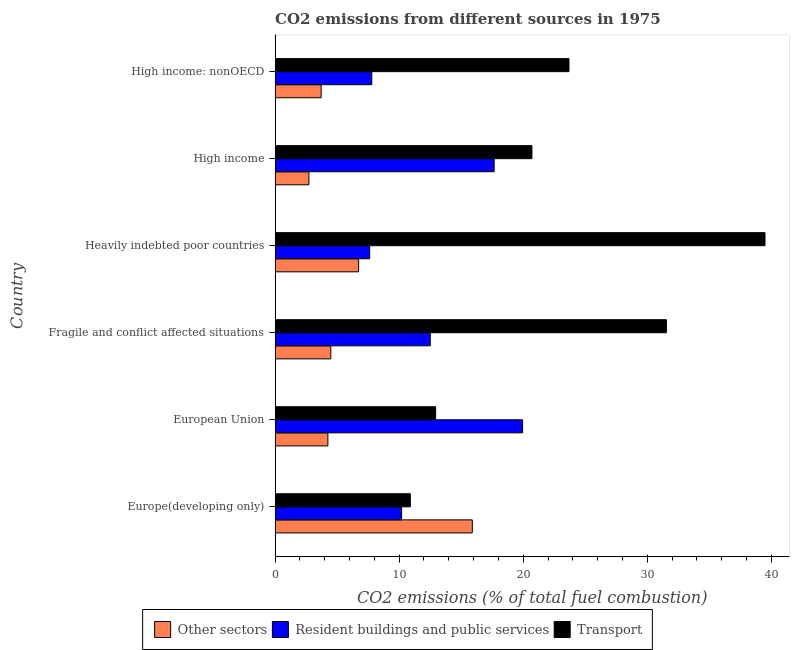How many groups of bars are there?
Offer a very short reply. 6. Are the number of bars on each tick of the Y-axis equal?
Your response must be concise. Yes. How many bars are there on the 3rd tick from the top?
Ensure brevity in your answer.  3. What is the label of the 6th group of bars from the top?
Offer a terse response. Europe(developing only). What is the percentage of co2 emissions from other sectors in High income?
Provide a succinct answer. 2.73. Across all countries, what is the maximum percentage of co2 emissions from transport?
Provide a short and direct response. 39.49. Across all countries, what is the minimum percentage of co2 emissions from other sectors?
Offer a very short reply. 2.73. In which country was the percentage of co2 emissions from resident buildings and public services minimum?
Offer a very short reply. Heavily indebted poor countries. What is the total percentage of co2 emissions from resident buildings and public services in the graph?
Your answer should be very brief. 75.72. What is the difference between the percentage of co2 emissions from other sectors in Europe(developing only) and that in High income?
Offer a very short reply. 13.17. What is the difference between the percentage of co2 emissions from transport in Fragile and conflict affected situations and the percentage of co2 emissions from resident buildings and public services in European Union?
Offer a terse response. 11.59. What is the average percentage of co2 emissions from other sectors per country?
Your response must be concise. 6.3. What is the difference between the percentage of co2 emissions from other sectors and percentage of co2 emissions from resident buildings and public services in High income: nonOECD?
Provide a short and direct response. -4.08. What is the ratio of the percentage of co2 emissions from transport in Europe(developing only) to that in High income?
Provide a succinct answer. 0.53. Is the percentage of co2 emissions from resident buildings and public services in Fragile and conflict affected situations less than that in High income: nonOECD?
Your answer should be very brief. No. Is the difference between the percentage of co2 emissions from transport in Heavily indebted poor countries and High income: nonOECD greater than the difference between the percentage of co2 emissions from resident buildings and public services in Heavily indebted poor countries and High income: nonOECD?
Provide a short and direct response. Yes. What is the difference between the highest and the second highest percentage of co2 emissions from resident buildings and public services?
Give a very brief answer. 2.3. What is the difference between the highest and the lowest percentage of co2 emissions from transport?
Your response must be concise. 28.58. In how many countries, is the percentage of co2 emissions from transport greater than the average percentage of co2 emissions from transport taken over all countries?
Provide a short and direct response. 3. What does the 2nd bar from the top in European Union represents?
Make the answer very short. Resident buildings and public services. What does the 1st bar from the bottom in Fragile and conflict affected situations represents?
Ensure brevity in your answer.  Other sectors. Is it the case that in every country, the sum of the percentage of co2 emissions from other sectors and percentage of co2 emissions from resident buildings and public services is greater than the percentage of co2 emissions from transport?
Offer a terse response. No. How many bars are there?
Keep it short and to the point. 18. What is the difference between two consecutive major ticks on the X-axis?
Ensure brevity in your answer.  10. Are the values on the major ticks of X-axis written in scientific E-notation?
Offer a very short reply. No. Does the graph contain grids?
Give a very brief answer. No. Where does the legend appear in the graph?
Provide a short and direct response. Bottom center. How are the legend labels stacked?
Your answer should be very brief. Horizontal. What is the title of the graph?
Offer a very short reply. CO2 emissions from different sources in 1975. Does "Self-employed" appear as one of the legend labels in the graph?
Provide a short and direct response. No. What is the label or title of the X-axis?
Provide a short and direct response. CO2 emissions (% of total fuel combustion). What is the CO2 emissions (% of total fuel combustion) in Other sectors in Europe(developing only)?
Make the answer very short. 15.89. What is the CO2 emissions (% of total fuel combustion) of Resident buildings and public services in Europe(developing only)?
Keep it short and to the point. 10.2. What is the CO2 emissions (% of total fuel combustion) in Transport in Europe(developing only)?
Give a very brief answer. 10.9. What is the CO2 emissions (% of total fuel combustion) of Other sectors in European Union?
Ensure brevity in your answer.  4.26. What is the CO2 emissions (% of total fuel combustion) of Resident buildings and public services in European Union?
Your answer should be very brief. 19.95. What is the CO2 emissions (% of total fuel combustion) in Transport in European Union?
Provide a short and direct response. 12.94. What is the CO2 emissions (% of total fuel combustion) of Other sectors in Fragile and conflict affected situations?
Provide a succinct answer. 4.49. What is the CO2 emissions (% of total fuel combustion) in Resident buildings and public services in Fragile and conflict affected situations?
Offer a very short reply. 12.51. What is the CO2 emissions (% of total fuel combustion) of Transport in Fragile and conflict affected situations?
Your response must be concise. 31.54. What is the CO2 emissions (% of total fuel combustion) of Other sectors in Heavily indebted poor countries?
Offer a very short reply. 6.73. What is the CO2 emissions (% of total fuel combustion) in Resident buildings and public services in Heavily indebted poor countries?
Provide a succinct answer. 7.62. What is the CO2 emissions (% of total fuel combustion) in Transport in Heavily indebted poor countries?
Offer a terse response. 39.49. What is the CO2 emissions (% of total fuel combustion) in Other sectors in High income?
Provide a short and direct response. 2.73. What is the CO2 emissions (% of total fuel combustion) of Resident buildings and public services in High income?
Offer a very short reply. 17.65. What is the CO2 emissions (% of total fuel combustion) of Transport in High income?
Keep it short and to the point. 20.7. What is the CO2 emissions (% of total fuel combustion) of Other sectors in High income: nonOECD?
Keep it short and to the point. 3.71. What is the CO2 emissions (% of total fuel combustion) of Resident buildings and public services in High income: nonOECD?
Your answer should be very brief. 7.79. What is the CO2 emissions (% of total fuel combustion) in Transport in High income: nonOECD?
Ensure brevity in your answer.  23.69. Across all countries, what is the maximum CO2 emissions (% of total fuel combustion) in Other sectors?
Make the answer very short. 15.89. Across all countries, what is the maximum CO2 emissions (% of total fuel combustion) of Resident buildings and public services?
Provide a short and direct response. 19.95. Across all countries, what is the maximum CO2 emissions (% of total fuel combustion) of Transport?
Provide a short and direct response. 39.49. Across all countries, what is the minimum CO2 emissions (% of total fuel combustion) of Other sectors?
Give a very brief answer. 2.73. Across all countries, what is the minimum CO2 emissions (% of total fuel combustion) of Resident buildings and public services?
Provide a succinct answer. 7.62. Across all countries, what is the minimum CO2 emissions (% of total fuel combustion) in Transport?
Offer a terse response. 10.9. What is the total CO2 emissions (% of total fuel combustion) of Other sectors in the graph?
Your answer should be compact. 37.82. What is the total CO2 emissions (% of total fuel combustion) of Resident buildings and public services in the graph?
Provide a succinct answer. 75.72. What is the total CO2 emissions (% of total fuel combustion) of Transport in the graph?
Provide a short and direct response. 139.26. What is the difference between the CO2 emissions (% of total fuel combustion) of Other sectors in Europe(developing only) and that in European Union?
Your response must be concise. 11.64. What is the difference between the CO2 emissions (% of total fuel combustion) of Resident buildings and public services in Europe(developing only) and that in European Union?
Provide a short and direct response. -9.75. What is the difference between the CO2 emissions (% of total fuel combustion) of Transport in Europe(developing only) and that in European Union?
Offer a terse response. -2.04. What is the difference between the CO2 emissions (% of total fuel combustion) of Other sectors in Europe(developing only) and that in Fragile and conflict affected situations?
Your response must be concise. 11.4. What is the difference between the CO2 emissions (% of total fuel combustion) in Resident buildings and public services in Europe(developing only) and that in Fragile and conflict affected situations?
Provide a short and direct response. -2.31. What is the difference between the CO2 emissions (% of total fuel combustion) of Transport in Europe(developing only) and that in Fragile and conflict affected situations?
Your response must be concise. -20.64. What is the difference between the CO2 emissions (% of total fuel combustion) in Other sectors in Europe(developing only) and that in Heavily indebted poor countries?
Give a very brief answer. 9.16. What is the difference between the CO2 emissions (% of total fuel combustion) in Resident buildings and public services in Europe(developing only) and that in Heavily indebted poor countries?
Keep it short and to the point. 2.57. What is the difference between the CO2 emissions (% of total fuel combustion) of Transport in Europe(developing only) and that in Heavily indebted poor countries?
Your answer should be very brief. -28.58. What is the difference between the CO2 emissions (% of total fuel combustion) in Other sectors in Europe(developing only) and that in High income?
Ensure brevity in your answer.  13.17. What is the difference between the CO2 emissions (% of total fuel combustion) in Resident buildings and public services in Europe(developing only) and that in High income?
Provide a short and direct response. -7.46. What is the difference between the CO2 emissions (% of total fuel combustion) of Transport in Europe(developing only) and that in High income?
Your answer should be compact. -9.8. What is the difference between the CO2 emissions (% of total fuel combustion) of Other sectors in Europe(developing only) and that in High income: nonOECD?
Make the answer very short. 12.18. What is the difference between the CO2 emissions (% of total fuel combustion) in Resident buildings and public services in Europe(developing only) and that in High income: nonOECD?
Offer a very short reply. 2.4. What is the difference between the CO2 emissions (% of total fuel combustion) in Transport in Europe(developing only) and that in High income: nonOECD?
Make the answer very short. -12.79. What is the difference between the CO2 emissions (% of total fuel combustion) of Other sectors in European Union and that in Fragile and conflict affected situations?
Keep it short and to the point. -0.24. What is the difference between the CO2 emissions (% of total fuel combustion) in Resident buildings and public services in European Union and that in Fragile and conflict affected situations?
Offer a terse response. 7.44. What is the difference between the CO2 emissions (% of total fuel combustion) in Transport in European Union and that in Fragile and conflict affected situations?
Your answer should be very brief. -18.6. What is the difference between the CO2 emissions (% of total fuel combustion) in Other sectors in European Union and that in Heavily indebted poor countries?
Keep it short and to the point. -2.48. What is the difference between the CO2 emissions (% of total fuel combustion) of Resident buildings and public services in European Union and that in Heavily indebted poor countries?
Offer a terse response. 12.33. What is the difference between the CO2 emissions (% of total fuel combustion) in Transport in European Union and that in Heavily indebted poor countries?
Offer a terse response. -26.54. What is the difference between the CO2 emissions (% of total fuel combustion) in Other sectors in European Union and that in High income?
Your answer should be compact. 1.53. What is the difference between the CO2 emissions (% of total fuel combustion) of Resident buildings and public services in European Union and that in High income?
Offer a terse response. 2.3. What is the difference between the CO2 emissions (% of total fuel combustion) in Transport in European Union and that in High income?
Provide a succinct answer. -7.76. What is the difference between the CO2 emissions (% of total fuel combustion) of Other sectors in European Union and that in High income: nonOECD?
Provide a succinct answer. 0.54. What is the difference between the CO2 emissions (% of total fuel combustion) in Resident buildings and public services in European Union and that in High income: nonOECD?
Your response must be concise. 12.16. What is the difference between the CO2 emissions (% of total fuel combustion) in Transport in European Union and that in High income: nonOECD?
Provide a short and direct response. -10.75. What is the difference between the CO2 emissions (% of total fuel combustion) of Other sectors in Fragile and conflict affected situations and that in Heavily indebted poor countries?
Your answer should be very brief. -2.24. What is the difference between the CO2 emissions (% of total fuel combustion) of Resident buildings and public services in Fragile and conflict affected situations and that in Heavily indebted poor countries?
Give a very brief answer. 4.88. What is the difference between the CO2 emissions (% of total fuel combustion) in Transport in Fragile and conflict affected situations and that in Heavily indebted poor countries?
Offer a terse response. -7.95. What is the difference between the CO2 emissions (% of total fuel combustion) of Other sectors in Fragile and conflict affected situations and that in High income?
Provide a succinct answer. 1.77. What is the difference between the CO2 emissions (% of total fuel combustion) in Resident buildings and public services in Fragile and conflict affected situations and that in High income?
Your answer should be compact. -5.15. What is the difference between the CO2 emissions (% of total fuel combustion) of Transport in Fragile and conflict affected situations and that in High income?
Offer a terse response. 10.84. What is the difference between the CO2 emissions (% of total fuel combustion) in Other sectors in Fragile and conflict affected situations and that in High income: nonOECD?
Give a very brief answer. 0.78. What is the difference between the CO2 emissions (% of total fuel combustion) in Resident buildings and public services in Fragile and conflict affected situations and that in High income: nonOECD?
Give a very brief answer. 4.71. What is the difference between the CO2 emissions (% of total fuel combustion) of Transport in Fragile and conflict affected situations and that in High income: nonOECD?
Offer a very short reply. 7.85. What is the difference between the CO2 emissions (% of total fuel combustion) in Other sectors in Heavily indebted poor countries and that in High income?
Give a very brief answer. 4.01. What is the difference between the CO2 emissions (% of total fuel combustion) of Resident buildings and public services in Heavily indebted poor countries and that in High income?
Keep it short and to the point. -10.03. What is the difference between the CO2 emissions (% of total fuel combustion) of Transport in Heavily indebted poor countries and that in High income?
Keep it short and to the point. 18.78. What is the difference between the CO2 emissions (% of total fuel combustion) in Other sectors in Heavily indebted poor countries and that in High income: nonOECD?
Give a very brief answer. 3.02. What is the difference between the CO2 emissions (% of total fuel combustion) in Resident buildings and public services in Heavily indebted poor countries and that in High income: nonOECD?
Make the answer very short. -0.17. What is the difference between the CO2 emissions (% of total fuel combustion) in Transport in Heavily indebted poor countries and that in High income: nonOECD?
Your answer should be compact. 15.8. What is the difference between the CO2 emissions (% of total fuel combustion) in Other sectors in High income and that in High income: nonOECD?
Offer a terse response. -0.99. What is the difference between the CO2 emissions (% of total fuel combustion) of Resident buildings and public services in High income and that in High income: nonOECD?
Your answer should be compact. 9.86. What is the difference between the CO2 emissions (% of total fuel combustion) of Transport in High income and that in High income: nonOECD?
Give a very brief answer. -2.99. What is the difference between the CO2 emissions (% of total fuel combustion) in Other sectors in Europe(developing only) and the CO2 emissions (% of total fuel combustion) in Resident buildings and public services in European Union?
Your response must be concise. -4.06. What is the difference between the CO2 emissions (% of total fuel combustion) of Other sectors in Europe(developing only) and the CO2 emissions (% of total fuel combustion) of Transport in European Union?
Offer a very short reply. 2.95. What is the difference between the CO2 emissions (% of total fuel combustion) of Resident buildings and public services in Europe(developing only) and the CO2 emissions (% of total fuel combustion) of Transport in European Union?
Your answer should be very brief. -2.74. What is the difference between the CO2 emissions (% of total fuel combustion) in Other sectors in Europe(developing only) and the CO2 emissions (% of total fuel combustion) in Resident buildings and public services in Fragile and conflict affected situations?
Offer a very short reply. 3.39. What is the difference between the CO2 emissions (% of total fuel combustion) of Other sectors in Europe(developing only) and the CO2 emissions (% of total fuel combustion) of Transport in Fragile and conflict affected situations?
Provide a succinct answer. -15.64. What is the difference between the CO2 emissions (% of total fuel combustion) in Resident buildings and public services in Europe(developing only) and the CO2 emissions (% of total fuel combustion) in Transport in Fragile and conflict affected situations?
Your answer should be very brief. -21.34. What is the difference between the CO2 emissions (% of total fuel combustion) in Other sectors in Europe(developing only) and the CO2 emissions (% of total fuel combustion) in Resident buildings and public services in Heavily indebted poor countries?
Make the answer very short. 8.27. What is the difference between the CO2 emissions (% of total fuel combustion) in Other sectors in Europe(developing only) and the CO2 emissions (% of total fuel combustion) in Transport in Heavily indebted poor countries?
Your answer should be very brief. -23.59. What is the difference between the CO2 emissions (% of total fuel combustion) in Resident buildings and public services in Europe(developing only) and the CO2 emissions (% of total fuel combustion) in Transport in Heavily indebted poor countries?
Your answer should be very brief. -29.29. What is the difference between the CO2 emissions (% of total fuel combustion) in Other sectors in Europe(developing only) and the CO2 emissions (% of total fuel combustion) in Resident buildings and public services in High income?
Make the answer very short. -1.76. What is the difference between the CO2 emissions (% of total fuel combustion) in Other sectors in Europe(developing only) and the CO2 emissions (% of total fuel combustion) in Transport in High income?
Give a very brief answer. -4.81. What is the difference between the CO2 emissions (% of total fuel combustion) in Resident buildings and public services in Europe(developing only) and the CO2 emissions (% of total fuel combustion) in Transport in High income?
Provide a succinct answer. -10.5. What is the difference between the CO2 emissions (% of total fuel combustion) in Other sectors in Europe(developing only) and the CO2 emissions (% of total fuel combustion) in Resident buildings and public services in High income: nonOECD?
Your answer should be very brief. 8.1. What is the difference between the CO2 emissions (% of total fuel combustion) of Other sectors in Europe(developing only) and the CO2 emissions (% of total fuel combustion) of Transport in High income: nonOECD?
Give a very brief answer. -7.79. What is the difference between the CO2 emissions (% of total fuel combustion) in Resident buildings and public services in Europe(developing only) and the CO2 emissions (% of total fuel combustion) in Transport in High income: nonOECD?
Your answer should be very brief. -13.49. What is the difference between the CO2 emissions (% of total fuel combustion) of Other sectors in European Union and the CO2 emissions (% of total fuel combustion) of Resident buildings and public services in Fragile and conflict affected situations?
Your answer should be compact. -8.25. What is the difference between the CO2 emissions (% of total fuel combustion) in Other sectors in European Union and the CO2 emissions (% of total fuel combustion) in Transport in Fragile and conflict affected situations?
Ensure brevity in your answer.  -27.28. What is the difference between the CO2 emissions (% of total fuel combustion) of Resident buildings and public services in European Union and the CO2 emissions (% of total fuel combustion) of Transport in Fragile and conflict affected situations?
Keep it short and to the point. -11.59. What is the difference between the CO2 emissions (% of total fuel combustion) of Other sectors in European Union and the CO2 emissions (% of total fuel combustion) of Resident buildings and public services in Heavily indebted poor countries?
Give a very brief answer. -3.37. What is the difference between the CO2 emissions (% of total fuel combustion) of Other sectors in European Union and the CO2 emissions (% of total fuel combustion) of Transport in Heavily indebted poor countries?
Offer a terse response. -35.23. What is the difference between the CO2 emissions (% of total fuel combustion) of Resident buildings and public services in European Union and the CO2 emissions (% of total fuel combustion) of Transport in Heavily indebted poor countries?
Provide a short and direct response. -19.54. What is the difference between the CO2 emissions (% of total fuel combustion) in Other sectors in European Union and the CO2 emissions (% of total fuel combustion) in Resident buildings and public services in High income?
Give a very brief answer. -13.4. What is the difference between the CO2 emissions (% of total fuel combustion) in Other sectors in European Union and the CO2 emissions (% of total fuel combustion) in Transport in High income?
Your answer should be compact. -16.44. What is the difference between the CO2 emissions (% of total fuel combustion) of Resident buildings and public services in European Union and the CO2 emissions (% of total fuel combustion) of Transport in High income?
Your answer should be compact. -0.75. What is the difference between the CO2 emissions (% of total fuel combustion) in Other sectors in European Union and the CO2 emissions (% of total fuel combustion) in Resident buildings and public services in High income: nonOECD?
Offer a very short reply. -3.54. What is the difference between the CO2 emissions (% of total fuel combustion) in Other sectors in European Union and the CO2 emissions (% of total fuel combustion) in Transport in High income: nonOECD?
Make the answer very short. -19.43. What is the difference between the CO2 emissions (% of total fuel combustion) in Resident buildings and public services in European Union and the CO2 emissions (% of total fuel combustion) in Transport in High income: nonOECD?
Give a very brief answer. -3.74. What is the difference between the CO2 emissions (% of total fuel combustion) in Other sectors in Fragile and conflict affected situations and the CO2 emissions (% of total fuel combustion) in Resident buildings and public services in Heavily indebted poor countries?
Give a very brief answer. -3.13. What is the difference between the CO2 emissions (% of total fuel combustion) of Other sectors in Fragile and conflict affected situations and the CO2 emissions (% of total fuel combustion) of Transport in Heavily indebted poor countries?
Provide a short and direct response. -34.99. What is the difference between the CO2 emissions (% of total fuel combustion) of Resident buildings and public services in Fragile and conflict affected situations and the CO2 emissions (% of total fuel combustion) of Transport in Heavily indebted poor countries?
Offer a terse response. -26.98. What is the difference between the CO2 emissions (% of total fuel combustion) in Other sectors in Fragile and conflict affected situations and the CO2 emissions (% of total fuel combustion) in Resident buildings and public services in High income?
Your answer should be very brief. -13.16. What is the difference between the CO2 emissions (% of total fuel combustion) of Other sectors in Fragile and conflict affected situations and the CO2 emissions (% of total fuel combustion) of Transport in High income?
Make the answer very short. -16.21. What is the difference between the CO2 emissions (% of total fuel combustion) of Resident buildings and public services in Fragile and conflict affected situations and the CO2 emissions (% of total fuel combustion) of Transport in High income?
Keep it short and to the point. -8.19. What is the difference between the CO2 emissions (% of total fuel combustion) of Other sectors in Fragile and conflict affected situations and the CO2 emissions (% of total fuel combustion) of Resident buildings and public services in High income: nonOECD?
Your answer should be very brief. -3.3. What is the difference between the CO2 emissions (% of total fuel combustion) in Other sectors in Fragile and conflict affected situations and the CO2 emissions (% of total fuel combustion) in Transport in High income: nonOECD?
Keep it short and to the point. -19.2. What is the difference between the CO2 emissions (% of total fuel combustion) in Resident buildings and public services in Fragile and conflict affected situations and the CO2 emissions (% of total fuel combustion) in Transport in High income: nonOECD?
Give a very brief answer. -11.18. What is the difference between the CO2 emissions (% of total fuel combustion) of Other sectors in Heavily indebted poor countries and the CO2 emissions (% of total fuel combustion) of Resident buildings and public services in High income?
Your answer should be compact. -10.92. What is the difference between the CO2 emissions (% of total fuel combustion) in Other sectors in Heavily indebted poor countries and the CO2 emissions (% of total fuel combustion) in Transport in High income?
Provide a short and direct response. -13.97. What is the difference between the CO2 emissions (% of total fuel combustion) in Resident buildings and public services in Heavily indebted poor countries and the CO2 emissions (% of total fuel combustion) in Transport in High income?
Offer a terse response. -13.08. What is the difference between the CO2 emissions (% of total fuel combustion) in Other sectors in Heavily indebted poor countries and the CO2 emissions (% of total fuel combustion) in Resident buildings and public services in High income: nonOECD?
Make the answer very short. -1.06. What is the difference between the CO2 emissions (% of total fuel combustion) of Other sectors in Heavily indebted poor countries and the CO2 emissions (% of total fuel combustion) of Transport in High income: nonOECD?
Provide a short and direct response. -16.95. What is the difference between the CO2 emissions (% of total fuel combustion) of Resident buildings and public services in Heavily indebted poor countries and the CO2 emissions (% of total fuel combustion) of Transport in High income: nonOECD?
Make the answer very short. -16.07. What is the difference between the CO2 emissions (% of total fuel combustion) in Other sectors in High income and the CO2 emissions (% of total fuel combustion) in Resident buildings and public services in High income: nonOECD?
Make the answer very short. -5.07. What is the difference between the CO2 emissions (% of total fuel combustion) of Other sectors in High income and the CO2 emissions (% of total fuel combustion) of Transport in High income: nonOECD?
Your answer should be compact. -20.96. What is the difference between the CO2 emissions (% of total fuel combustion) of Resident buildings and public services in High income and the CO2 emissions (% of total fuel combustion) of Transport in High income: nonOECD?
Offer a very short reply. -6.03. What is the average CO2 emissions (% of total fuel combustion) of Other sectors per country?
Your answer should be very brief. 6.3. What is the average CO2 emissions (% of total fuel combustion) in Resident buildings and public services per country?
Your response must be concise. 12.62. What is the average CO2 emissions (% of total fuel combustion) in Transport per country?
Make the answer very short. 23.21. What is the difference between the CO2 emissions (% of total fuel combustion) in Other sectors and CO2 emissions (% of total fuel combustion) in Resident buildings and public services in Europe(developing only)?
Provide a succinct answer. 5.7. What is the difference between the CO2 emissions (% of total fuel combustion) of Other sectors and CO2 emissions (% of total fuel combustion) of Transport in Europe(developing only)?
Make the answer very short. 4.99. What is the difference between the CO2 emissions (% of total fuel combustion) in Resident buildings and public services and CO2 emissions (% of total fuel combustion) in Transport in Europe(developing only)?
Offer a very short reply. -0.71. What is the difference between the CO2 emissions (% of total fuel combustion) in Other sectors and CO2 emissions (% of total fuel combustion) in Resident buildings and public services in European Union?
Offer a terse response. -15.69. What is the difference between the CO2 emissions (% of total fuel combustion) in Other sectors and CO2 emissions (% of total fuel combustion) in Transport in European Union?
Provide a succinct answer. -8.68. What is the difference between the CO2 emissions (% of total fuel combustion) of Resident buildings and public services and CO2 emissions (% of total fuel combustion) of Transport in European Union?
Keep it short and to the point. 7.01. What is the difference between the CO2 emissions (% of total fuel combustion) in Other sectors and CO2 emissions (% of total fuel combustion) in Resident buildings and public services in Fragile and conflict affected situations?
Ensure brevity in your answer.  -8.01. What is the difference between the CO2 emissions (% of total fuel combustion) of Other sectors and CO2 emissions (% of total fuel combustion) of Transport in Fragile and conflict affected situations?
Offer a terse response. -27.05. What is the difference between the CO2 emissions (% of total fuel combustion) in Resident buildings and public services and CO2 emissions (% of total fuel combustion) in Transport in Fragile and conflict affected situations?
Provide a succinct answer. -19.03. What is the difference between the CO2 emissions (% of total fuel combustion) of Other sectors and CO2 emissions (% of total fuel combustion) of Resident buildings and public services in Heavily indebted poor countries?
Keep it short and to the point. -0.89. What is the difference between the CO2 emissions (% of total fuel combustion) of Other sectors and CO2 emissions (% of total fuel combustion) of Transport in Heavily indebted poor countries?
Keep it short and to the point. -32.75. What is the difference between the CO2 emissions (% of total fuel combustion) in Resident buildings and public services and CO2 emissions (% of total fuel combustion) in Transport in Heavily indebted poor countries?
Your response must be concise. -31.86. What is the difference between the CO2 emissions (% of total fuel combustion) of Other sectors and CO2 emissions (% of total fuel combustion) of Resident buildings and public services in High income?
Make the answer very short. -14.93. What is the difference between the CO2 emissions (% of total fuel combustion) in Other sectors and CO2 emissions (% of total fuel combustion) in Transport in High income?
Offer a terse response. -17.97. What is the difference between the CO2 emissions (% of total fuel combustion) in Resident buildings and public services and CO2 emissions (% of total fuel combustion) in Transport in High income?
Provide a short and direct response. -3.05. What is the difference between the CO2 emissions (% of total fuel combustion) in Other sectors and CO2 emissions (% of total fuel combustion) in Resident buildings and public services in High income: nonOECD?
Ensure brevity in your answer.  -4.08. What is the difference between the CO2 emissions (% of total fuel combustion) in Other sectors and CO2 emissions (% of total fuel combustion) in Transport in High income: nonOECD?
Your response must be concise. -19.98. What is the difference between the CO2 emissions (% of total fuel combustion) of Resident buildings and public services and CO2 emissions (% of total fuel combustion) of Transport in High income: nonOECD?
Give a very brief answer. -15.9. What is the ratio of the CO2 emissions (% of total fuel combustion) in Other sectors in Europe(developing only) to that in European Union?
Provide a short and direct response. 3.73. What is the ratio of the CO2 emissions (% of total fuel combustion) of Resident buildings and public services in Europe(developing only) to that in European Union?
Ensure brevity in your answer.  0.51. What is the ratio of the CO2 emissions (% of total fuel combustion) of Transport in Europe(developing only) to that in European Union?
Keep it short and to the point. 0.84. What is the ratio of the CO2 emissions (% of total fuel combustion) in Other sectors in Europe(developing only) to that in Fragile and conflict affected situations?
Offer a terse response. 3.54. What is the ratio of the CO2 emissions (% of total fuel combustion) in Resident buildings and public services in Europe(developing only) to that in Fragile and conflict affected situations?
Give a very brief answer. 0.82. What is the ratio of the CO2 emissions (% of total fuel combustion) in Transport in Europe(developing only) to that in Fragile and conflict affected situations?
Give a very brief answer. 0.35. What is the ratio of the CO2 emissions (% of total fuel combustion) in Other sectors in Europe(developing only) to that in Heavily indebted poor countries?
Keep it short and to the point. 2.36. What is the ratio of the CO2 emissions (% of total fuel combustion) in Resident buildings and public services in Europe(developing only) to that in Heavily indebted poor countries?
Offer a very short reply. 1.34. What is the ratio of the CO2 emissions (% of total fuel combustion) in Transport in Europe(developing only) to that in Heavily indebted poor countries?
Make the answer very short. 0.28. What is the ratio of the CO2 emissions (% of total fuel combustion) in Other sectors in Europe(developing only) to that in High income?
Your answer should be very brief. 5.83. What is the ratio of the CO2 emissions (% of total fuel combustion) in Resident buildings and public services in Europe(developing only) to that in High income?
Your response must be concise. 0.58. What is the ratio of the CO2 emissions (% of total fuel combustion) in Transport in Europe(developing only) to that in High income?
Keep it short and to the point. 0.53. What is the ratio of the CO2 emissions (% of total fuel combustion) of Other sectors in Europe(developing only) to that in High income: nonOECD?
Keep it short and to the point. 4.28. What is the ratio of the CO2 emissions (% of total fuel combustion) in Resident buildings and public services in Europe(developing only) to that in High income: nonOECD?
Offer a very short reply. 1.31. What is the ratio of the CO2 emissions (% of total fuel combustion) in Transport in Europe(developing only) to that in High income: nonOECD?
Provide a short and direct response. 0.46. What is the ratio of the CO2 emissions (% of total fuel combustion) in Other sectors in European Union to that in Fragile and conflict affected situations?
Your answer should be compact. 0.95. What is the ratio of the CO2 emissions (% of total fuel combustion) in Resident buildings and public services in European Union to that in Fragile and conflict affected situations?
Offer a terse response. 1.6. What is the ratio of the CO2 emissions (% of total fuel combustion) of Transport in European Union to that in Fragile and conflict affected situations?
Ensure brevity in your answer.  0.41. What is the ratio of the CO2 emissions (% of total fuel combustion) of Other sectors in European Union to that in Heavily indebted poor countries?
Provide a succinct answer. 0.63. What is the ratio of the CO2 emissions (% of total fuel combustion) in Resident buildings and public services in European Union to that in Heavily indebted poor countries?
Your answer should be compact. 2.62. What is the ratio of the CO2 emissions (% of total fuel combustion) in Transport in European Union to that in Heavily indebted poor countries?
Your response must be concise. 0.33. What is the ratio of the CO2 emissions (% of total fuel combustion) in Other sectors in European Union to that in High income?
Your answer should be compact. 1.56. What is the ratio of the CO2 emissions (% of total fuel combustion) in Resident buildings and public services in European Union to that in High income?
Make the answer very short. 1.13. What is the ratio of the CO2 emissions (% of total fuel combustion) of Transport in European Union to that in High income?
Ensure brevity in your answer.  0.63. What is the ratio of the CO2 emissions (% of total fuel combustion) in Other sectors in European Union to that in High income: nonOECD?
Provide a succinct answer. 1.15. What is the ratio of the CO2 emissions (% of total fuel combustion) of Resident buildings and public services in European Union to that in High income: nonOECD?
Offer a terse response. 2.56. What is the ratio of the CO2 emissions (% of total fuel combustion) in Transport in European Union to that in High income: nonOECD?
Your response must be concise. 0.55. What is the ratio of the CO2 emissions (% of total fuel combustion) in Other sectors in Fragile and conflict affected situations to that in Heavily indebted poor countries?
Provide a succinct answer. 0.67. What is the ratio of the CO2 emissions (% of total fuel combustion) in Resident buildings and public services in Fragile and conflict affected situations to that in Heavily indebted poor countries?
Give a very brief answer. 1.64. What is the ratio of the CO2 emissions (% of total fuel combustion) of Transport in Fragile and conflict affected situations to that in Heavily indebted poor countries?
Your answer should be very brief. 0.8. What is the ratio of the CO2 emissions (% of total fuel combustion) of Other sectors in Fragile and conflict affected situations to that in High income?
Your answer should be very brief. 1.65. What is the ratio of the CO2 emissions (% of total fuel combustion) in Resident buildings and public services in Fragile and conflict affected situations to that in High income?
Your response must be concise. 0.71. What is the ratio of the CO2 emissions (% of total fuel combustion) of Transport in Fragile and conflict affected situations to that in High income?
Your answer should be very brief. 1.52. What is the ratio of the CO2 emissions (% of total fuel combustion) in Other sectors in Fragile and conflict affected situations to that in High income: nonOECD?
Provide a short and direct response. 1.21. What is the ratio of the CO2 emissions (% of total fuel combustion) of Resident buildings and public services in Fragile and conflict affected situations to that in High income: nonOECD?
Offer a very short reply. 1.6. What is the ratio of the CO2 emissions (% of total fuel combustion) in Transport in Fragile and conflict affected situations to that in High income: nonOECD?
Your answer should be very brief. 1.33. What is the ratio of the CO2 emissions (% of total fuel combustion) in Other sectors in Heavily indebted poor countries to that in High income?
Give a very brief answer. 2.47. What is the ratio of the CO2 emissions (% of total fuel combustion) of Resident buildings and public services in Heavily indebted poor countries to that in High income?
Your answer should be very brief. 0.43. What is the ratio of the CO2 emissions (% of total fuel combustion) in Transport in Heavily indebted poor countries to that in High income?
Your answer should be compact. 1.91. What is the ratio of the CO2 emissions (% of total fuel combustion) of Other sectors in Heavily indebted poor countries to that in High income: nonOECD?
Give a very brief answer. 1.81. What is the ratio of the CO2 emissions (% of total fuel combustion) in Resident buildings and public services in Heavily indebted poor countries to that in High income: nonOECD?
Give a very brief answer. 0.98. What is the ratio of the CO2 emissions (% of total fuel combustion) of Transport in Heavily indebted poor countries to that in High income: nonOECD?
Make the answer very short. 1.67. What is the ratio of the CO2 emissions (% of total fuel combustion) in Other sectors in High income to that in High income: nonOECD?
Make the answer very short. 0.73. What is the ratio of the CO2 emissions (% of total fuel combustion) in Resident buildings and public services in High income to that in High income: nonOECD?
Your answer should be compact. 2.27. What is the ratio of the CO2 emissions (% of total fuel combustion) of Transport in High income to that in High income: nonOECD?
Provide a short and direct response. 0.87. What is the difference between the highest and the second highest CO2 emissions (% of total fuel combustion) in Other sectors?
Keep it short and to the point. 9.16. What is the difference between the highest and the second highest CO2 emissions (% of total fuel combustion) of Resident buildings and public services?
Make the answer very short. 2.3. What is the difference between the highest and the second highest CO2 emissions (% of total fuel combustion) in Transport?
Offer a very short reply. 7.95. What is the difference between the highest and the lowest CO2 emissions (% of total fuel combustion) in Other sectors?
Offer a very short reply. 13.17. What is the difference between the highest and the lowest CO2 emissions (% of total fuel combustion) in Resident buildings and public services?
Provide a short and direct response. 12.33. What is the difference between the highest and the lowest CO2 emissions (% of total fuel combustion) of Transport?
Give a very brief answer. 28.58. 